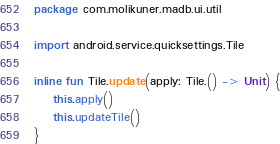<code> <loc_0><loc_0><loc_500><loc_500><_Kotlin_>package com.molikuner.madb.ui.util

import android.service.quicksettings.Tile

inline fun Tile.update(apply: Tile.() -> Unit) {
    this.apply()
    this.updateTile()
}</code> 